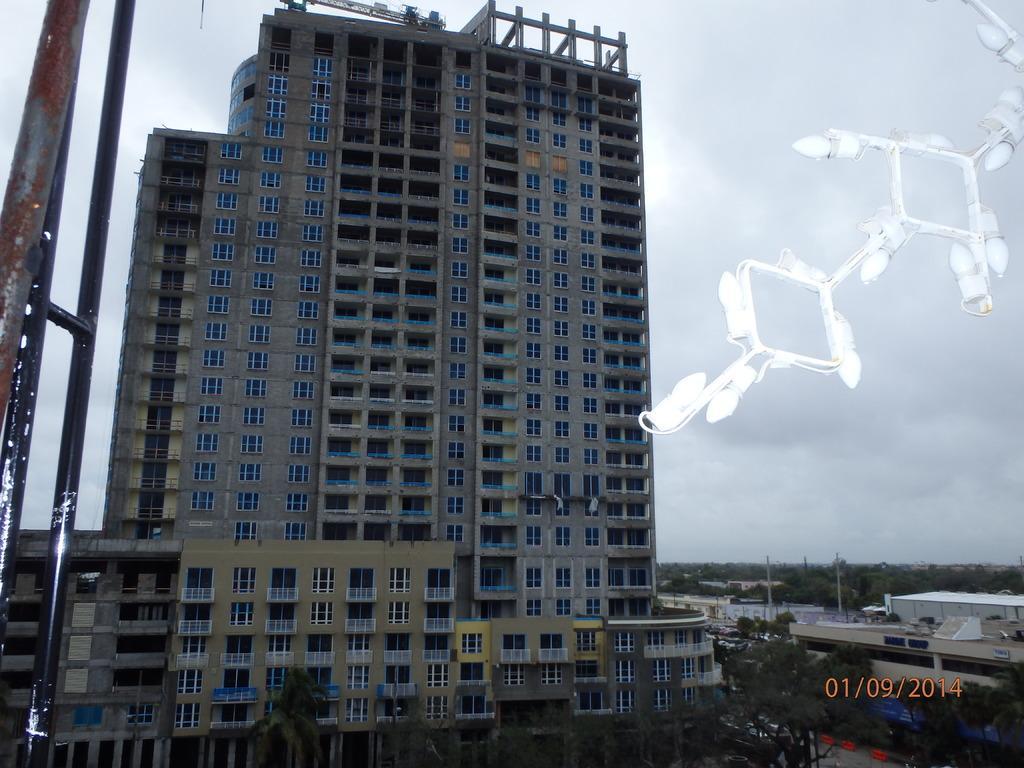How would you summarize this image in a sentence or two? In this image, we can see a building, there are some trees and at the top there is a sky. 